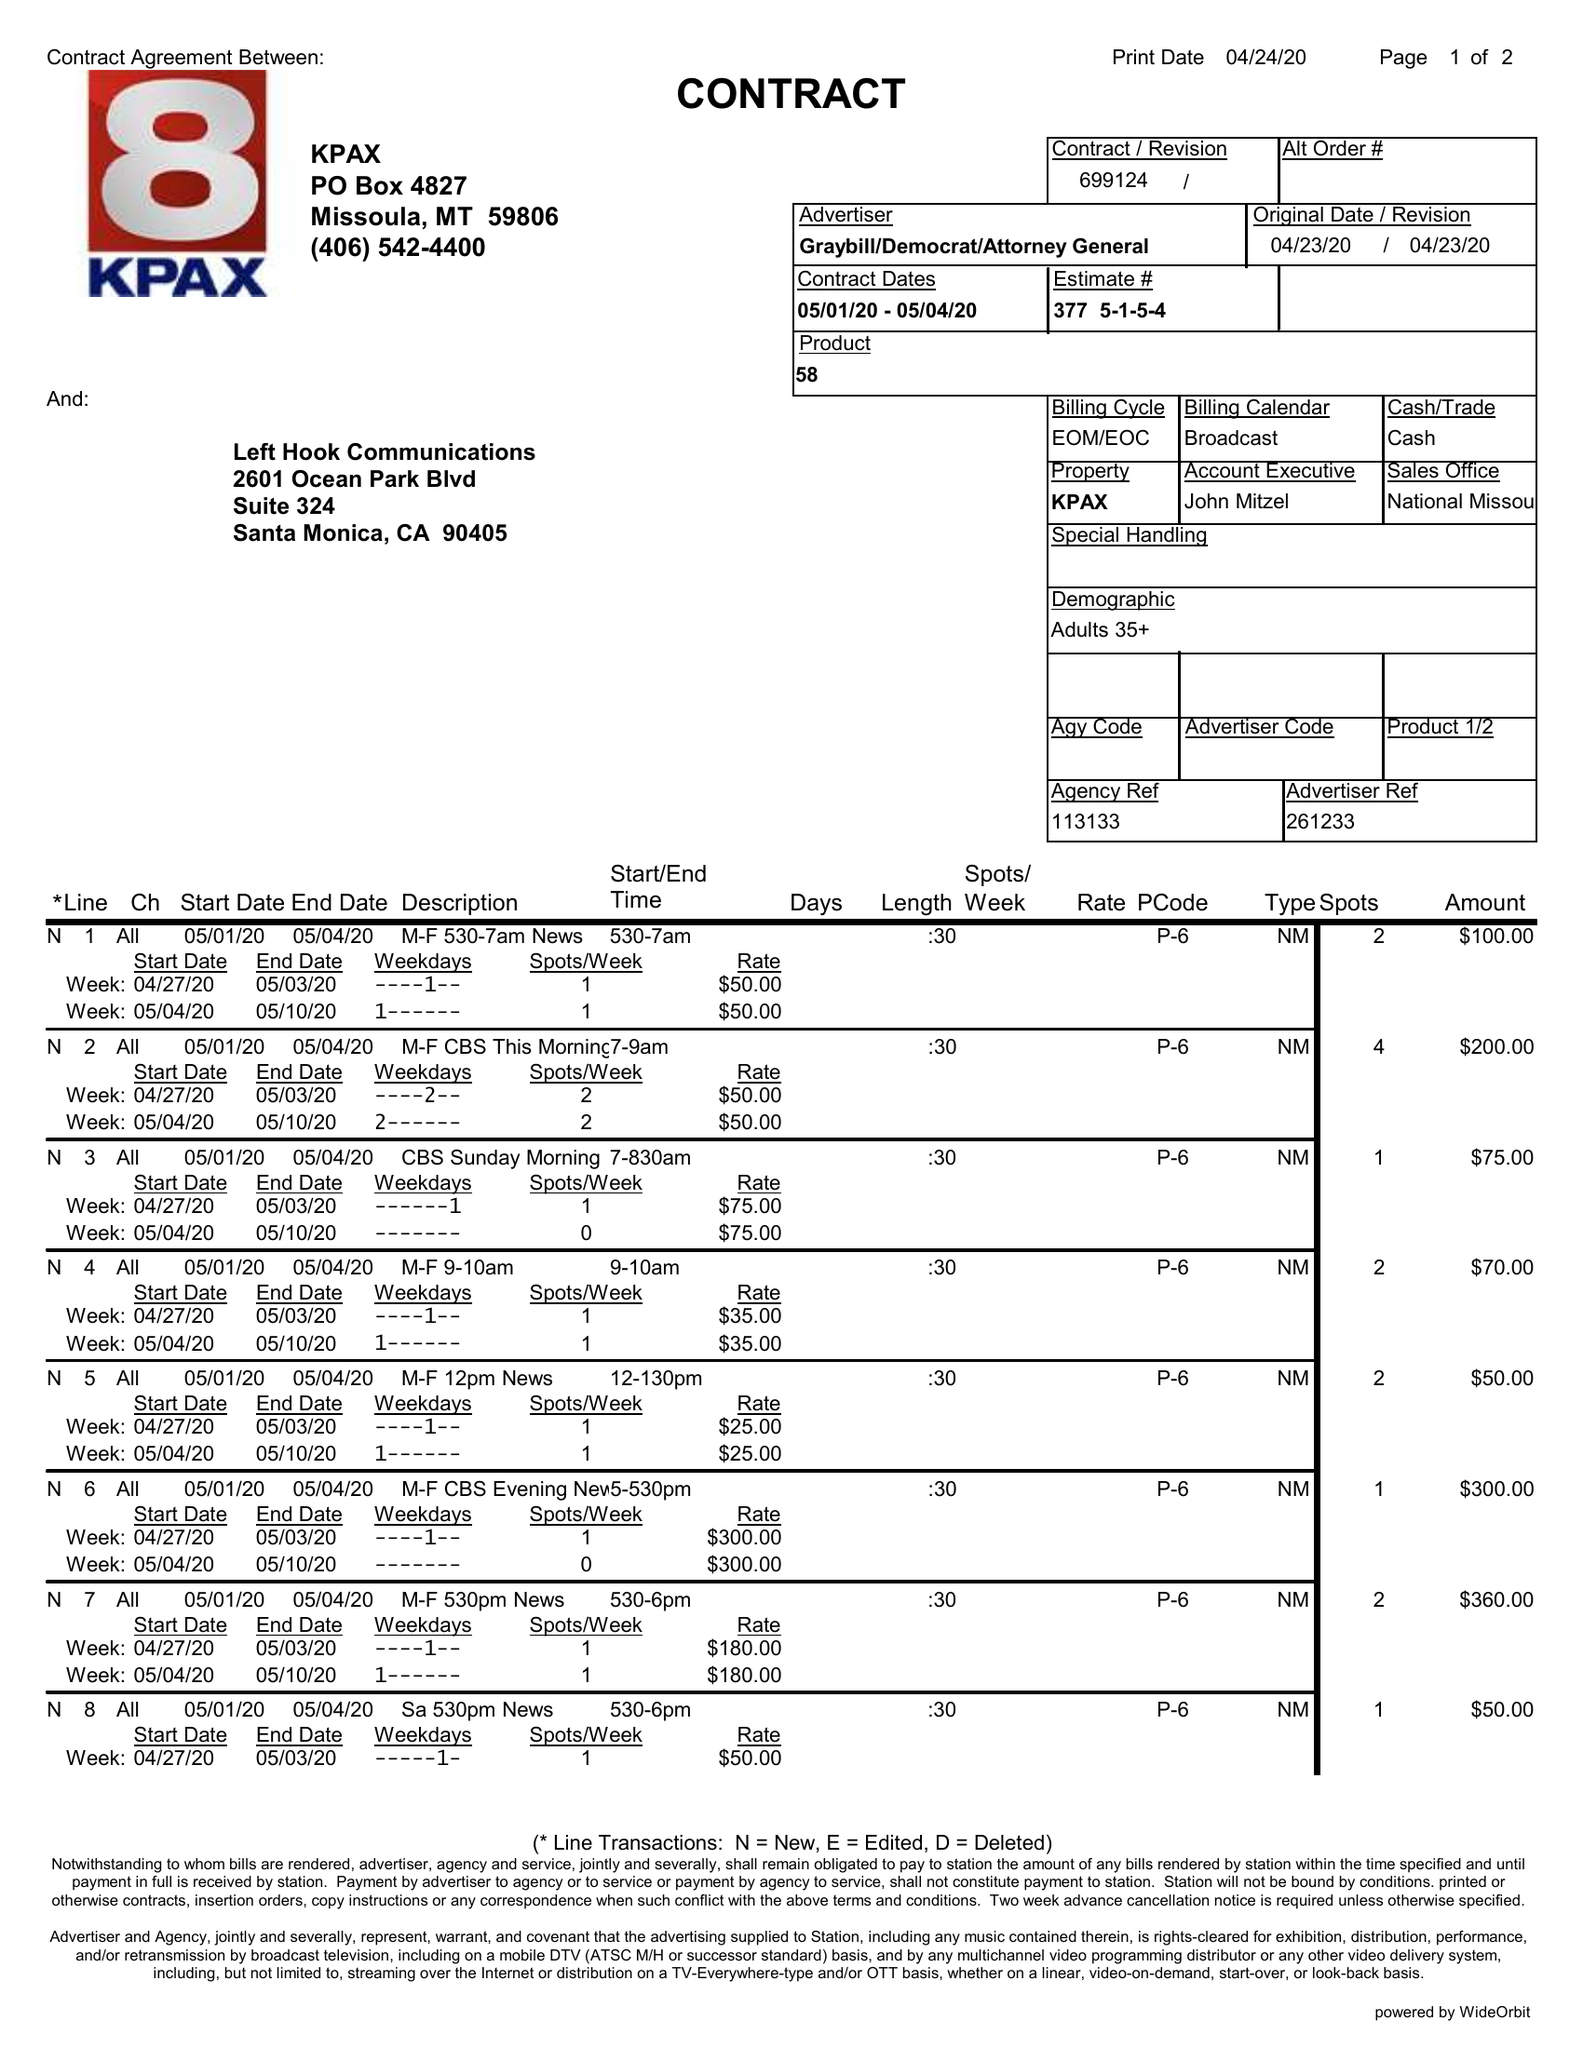What is the value for the gross_amount?
Answer the question using a single word or phrase. 2165.00 